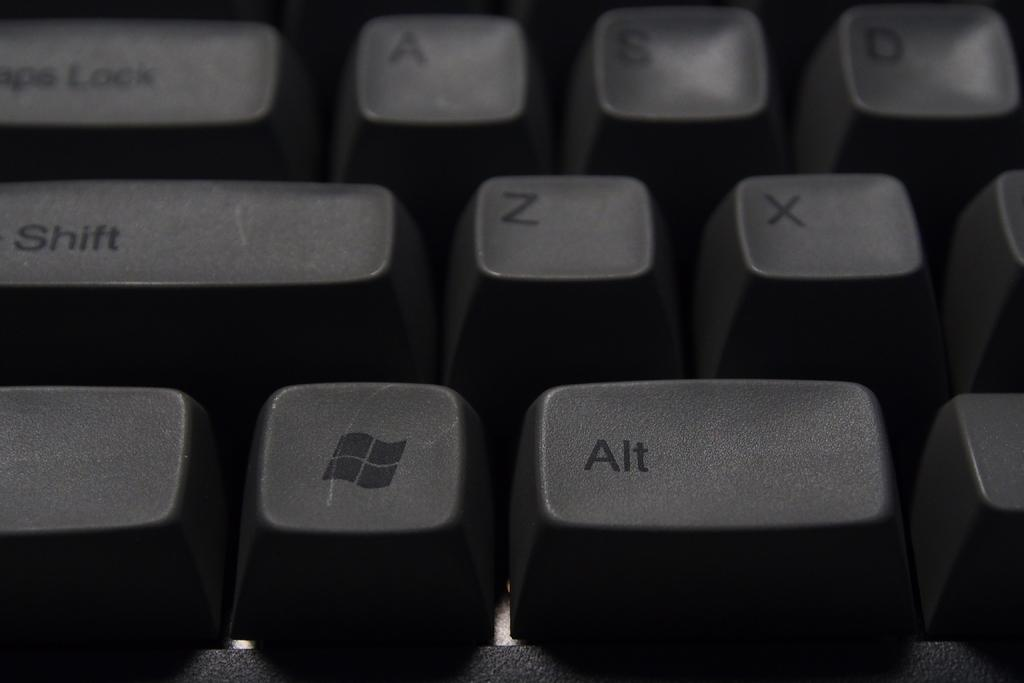What object is the main focus of the image? There is a keyboard in the image. Can you describe the keyboard in more detail? The keyboard appears to have keys and may be used for typing or playing music. What might someone be doing with the keyboard in the image? Someone might be typing on the keyboard or using it to play music. How many cherries are on the keyboard in the image? There are no cherries present on the keyboard in the image. What type of nail is being used to play the keyboard in the image? There is no nail being used to play the keyboard in the image; it is likely being played with fingers or a keyboard instrument accessory. 